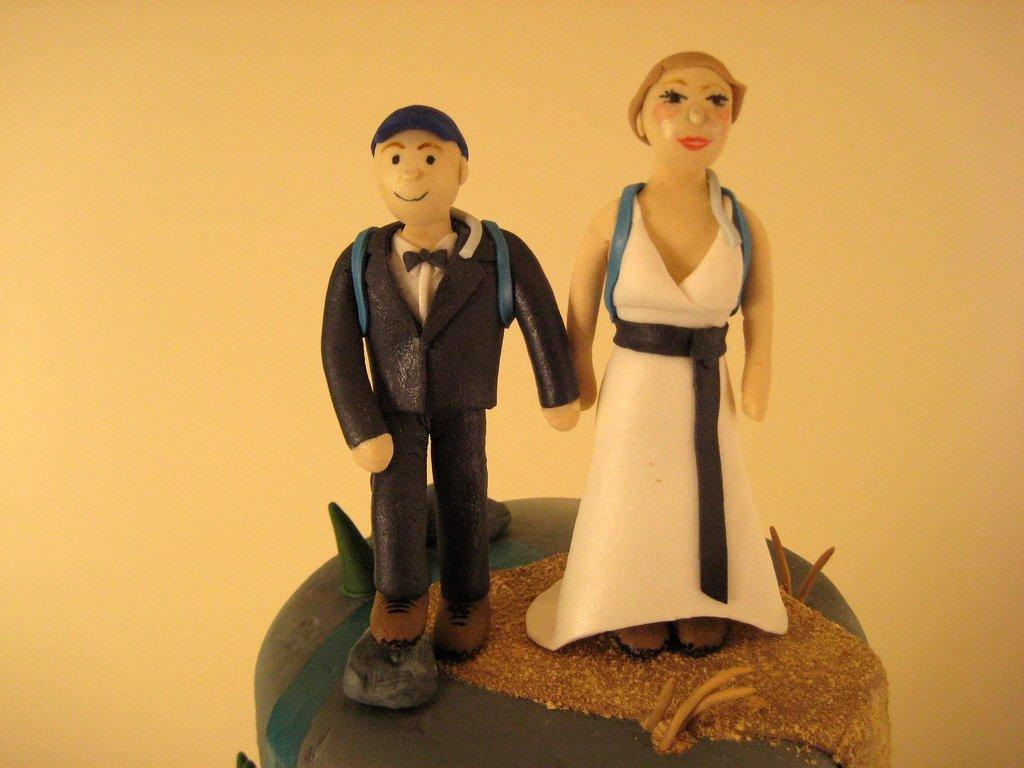What is the main subject at the bottom of the image? There is a cake at the bottom of the image. How many cakes are stacked on top of the bottom cake? There are two cakes on top of the bottom cake. What can be seen in the background of the image? The background of the image features a plane. What type of scissors can be seen cutting the top cake in the image? There are no scissors present in the image, and no cutting of the cake is depicted. 